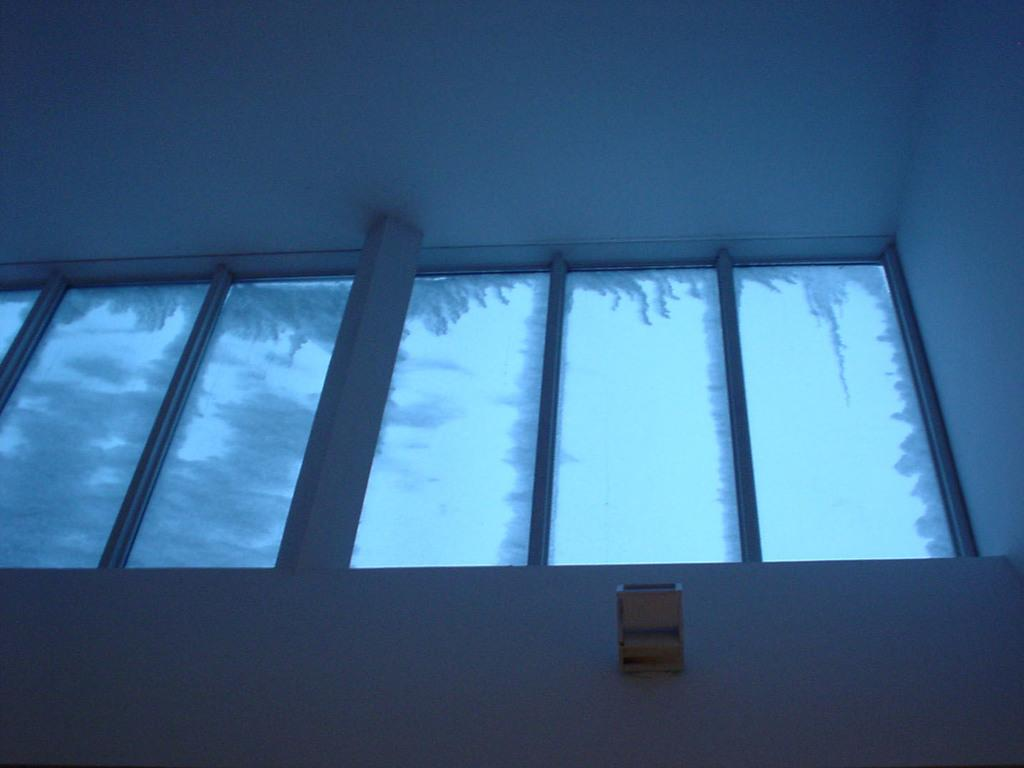What type of openings can be seen in the image? There are windows in the image. What objects are visible in the image that are typically used for drinking? There are glasses in the image. What type of structure is visible in the background of the image? There is a wall in the background of the image. How does the elbow contribute to the design of the windows in the image? There is no mention of an elbow in the image, and it does not contribute to the design of the windows. What type of writing instrument is used in the image? There is no mention of a quill or any writing instrument in the image. 